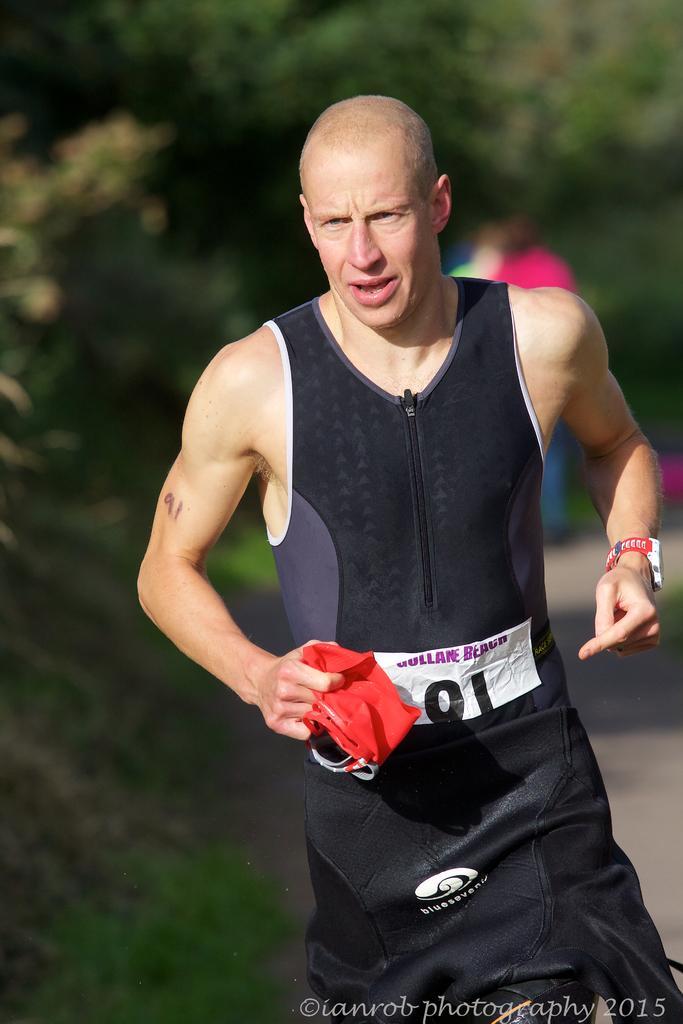Could you give a brief overview of what you see in this image? In this image there is a man who is holding the cloth. In the background there are trees. The man looks like a runner. There is a badge to his shirt. 